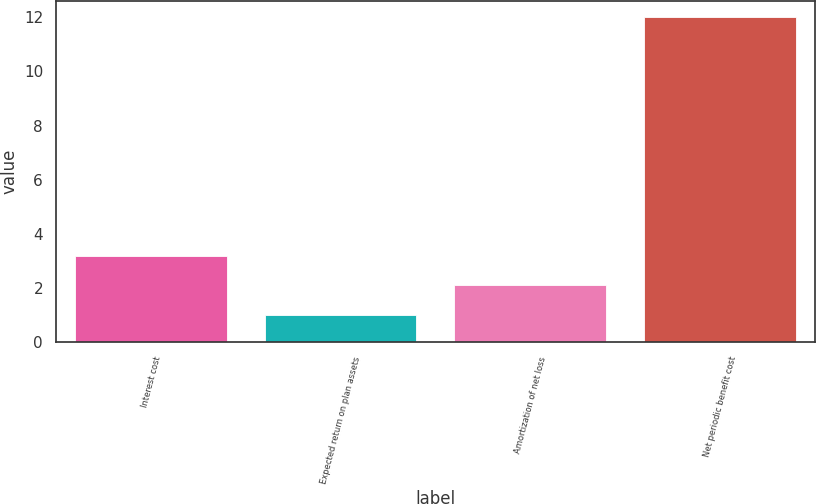Convert chart to OTSL. <chart><loc_0><loc_0><loc_500><loc_500><bar_chart><fcel>Interest cost<fcel>Expected return on plan assets<fcel>Amortization of net loss<fcel>Net periodic benefit cost<nl><fcel>3.2<fcel>1<fcel>2.1<fcel>12<nl></chart> 